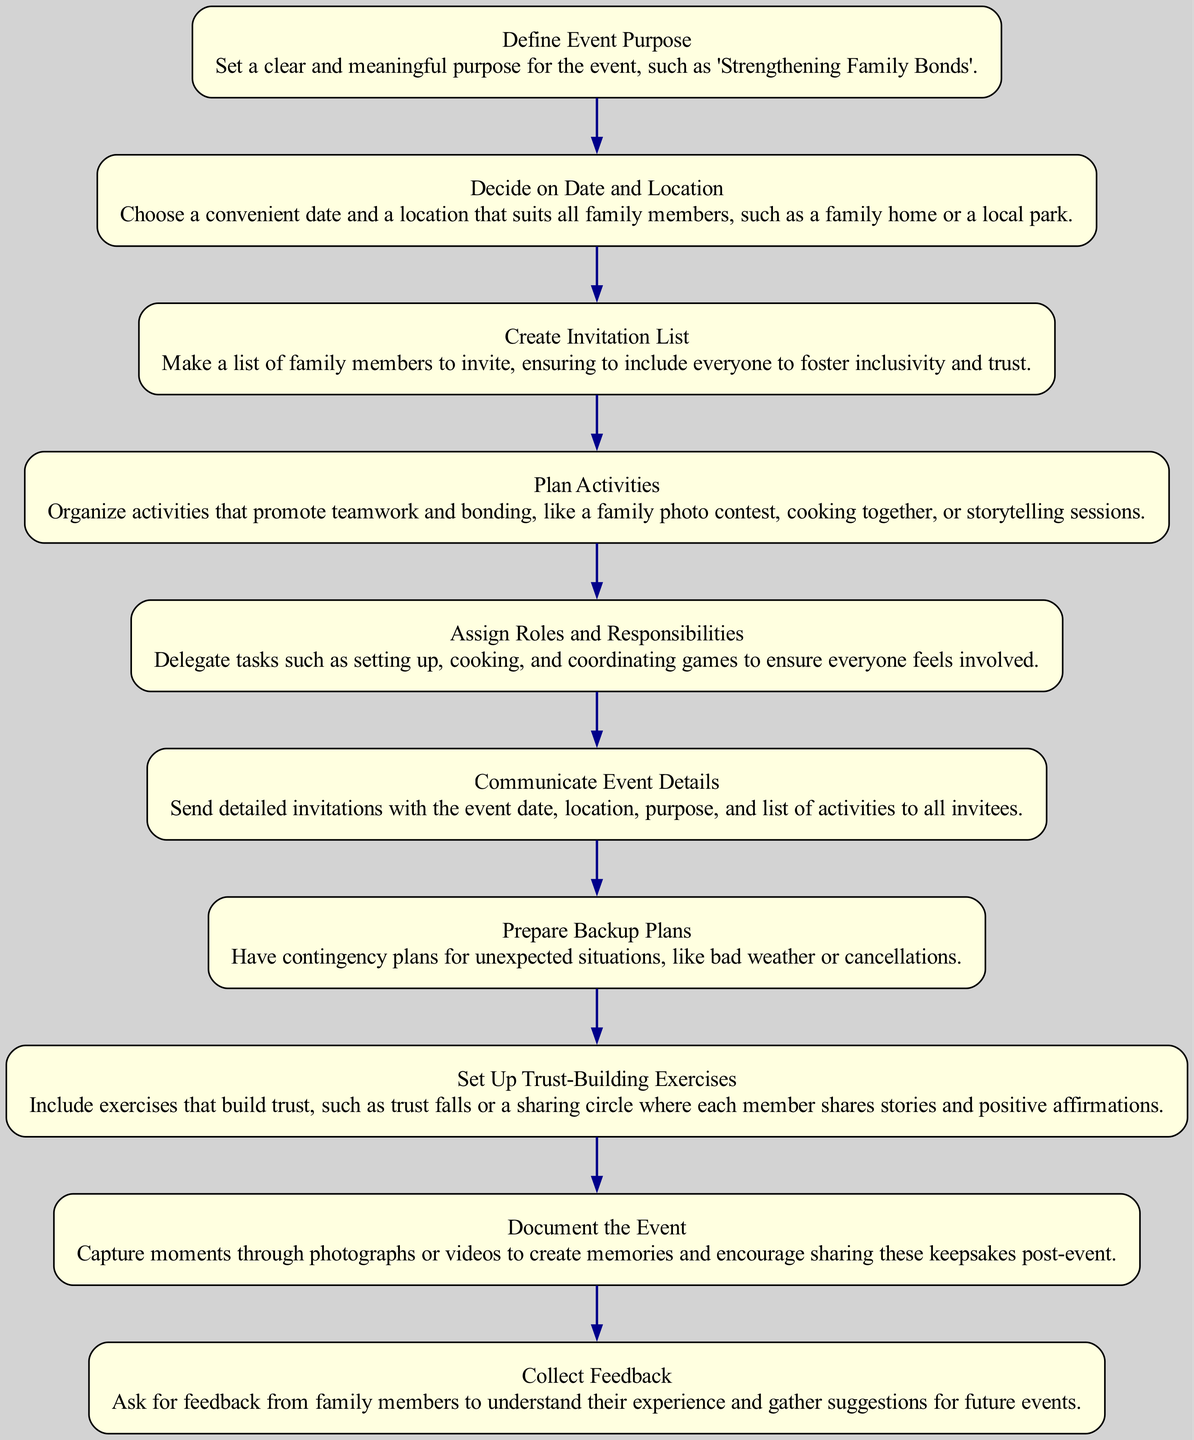What is the first step in organizing the family event? The first step is defined as "Define Event Purpose", which emphasizes setting a clear and meaningful purpose for the event.
Answer: Define Event Purpose How many total steps are there in the diagram? Counting the elements listed in the flowchart, there are 10 distinct steps from "Define Event Purpose" to "Collect Feedback".
Answer: 10 What is the purpose of the "Assign Roles and Responsibilities" step? This step is about delegating tasks like setting up and cooking, making sure everyone feels included and engaged in the event.
Answer: Delegate tasks What kind of activities are suggested to promote bonding? The diagram mentions activities such as a family photo contest, cooking together, or storytelling sessions, specifically targeted to enhance teamwork.
Answer: Family photo contest, cooking together, storytelling sessions What should be included in "Communicate Event Details"? This step requires sending detailed invitations containing the date, location, purpose, and activities, ensuring everyone understands the event's details.
Answer: Send detailed invitations Why is it important to "Prepare Backup Plans"? Having backup plans is crucial for managing unexpected situations like bad weather or cancellations, demonstrating foresight and ensuring the event's success.
Answer: Contingency plans How does the "Set Up Trust-Building Exercises" step contribute to the event? This step focuses on implementing activities such as trust falls or sharing circles that are designed to enhance trust amongst family members during the event.
Answer: Enhance trust Which step comes after "Plan Activities"? Following the "Plan Activities" step is "Assign Roles and Responsibilities," which ensures that the planned activities are effectively executed by all family members.
Answer: Assign Roles and Responsibilities What should be done after the event according to the flowchart? After the event, the next recommended step is to "Collect Feedback," which involves asking family members about their experiences and gathering suggestions for future improvements.
Answer: Collect Feedback 